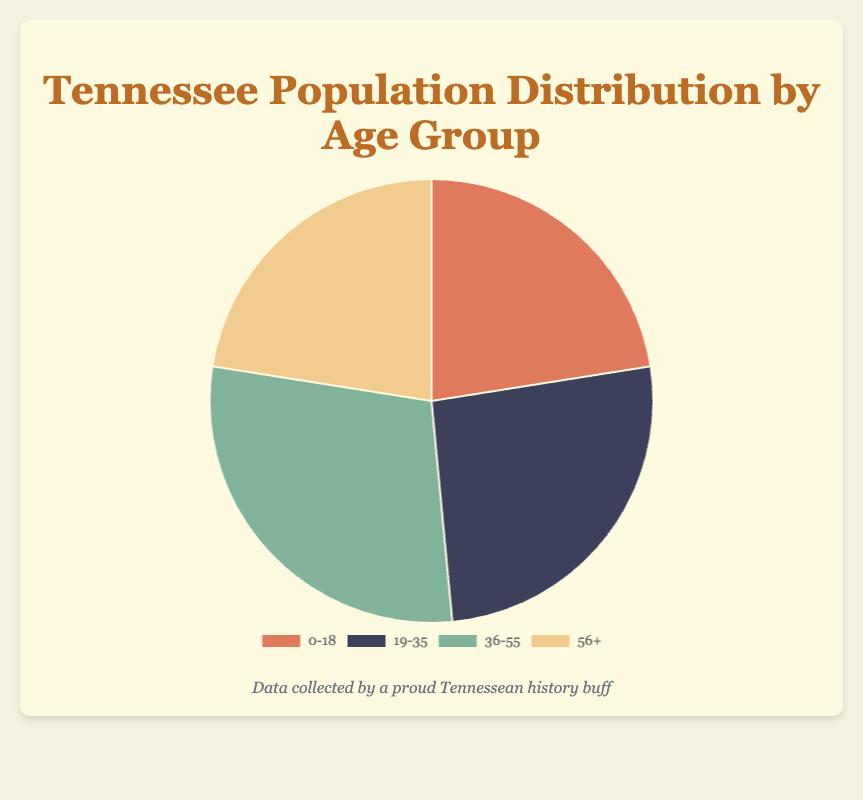What is the age group with the largest population percentage? The pie chart shows the percentages of different age groups. The age group 36-55 has the largest percentage at 29%.
Answer: 36-55 How many age groups have the same percentage of population? By observing the pie chart, the age groups 0-18 and 56+ both have a population percentage of 22.5%.
Answer: 2 What is the total percentage of the population for people aged below 36? Sum the percentages of the age groups 0-18 and 19-35. (22.5% + 26.0% = 48.5%)
Answer: 48.5% Which age group has the smallest population percentage? Comparing the percentages, the age groups 0-18 and 56+ both are the smallest with 22.5%.
Answer: 0-18 and 56+ By how much does the population percentage of age group 36-55 exceed that of age group 0-18? Subtract the percentage of the 0-18 group from the 36-55 group (29% - 22.5% = 6.5%).
Answer: 6.5% Which age group is highlighted in green? From the visual information, the green section corresponds to the age group 36-55.
Answer: 36-55 Is the population percentage of age group 19-35 greater than the combined percentage of age groups 0-18 and 56+? Sum the percentages of the age groups 0-18 and 56+ and compare to the 19-35 group. (22.5% + 22.5% = 45%, which is greater than 26%).
Answer: No What is the difference in population percentage between the oldest age group (56+) and the age group 19-35? Subtract the percentage of age group 56+ from 19-35 (26% - 22.5% = 3.5%).
Answer: 3.5% What is the average population percentage among all age groups? Sum all group percentages and divide by the number of groups. (22.5% + 26% + 29% + 22.5%) / 4 = 25.0%
Answer: 25.0% 